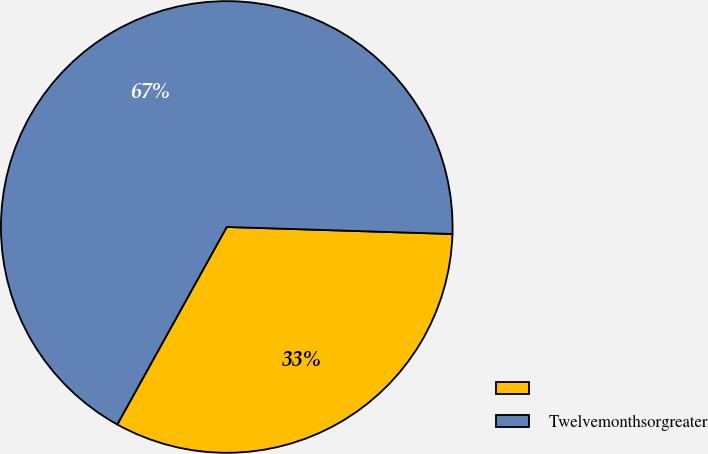Convert chart. <chart><loc_0><loc_0><loc_500><loc_500><pie_chart><ecel><fcel>Twelvemonthsorgreater<nl><fcel>32.56%<fcel>67.44%<nl></chart> 